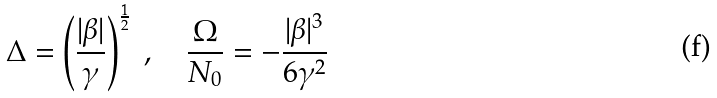Convert formula to latex. <formula><loc_0><loc_0><loc_500><loc_500>\Delta = \left ( \frac { | \beta | } { \gamma } \right ) ^ { \frac { 1 } { 2 } } \ , \quad \frac { \Omega } { N _ { 0 } } = - \frac { | \beta | ^ { 3 } } { 6 \gamma ^ { 2 } }</formula> 